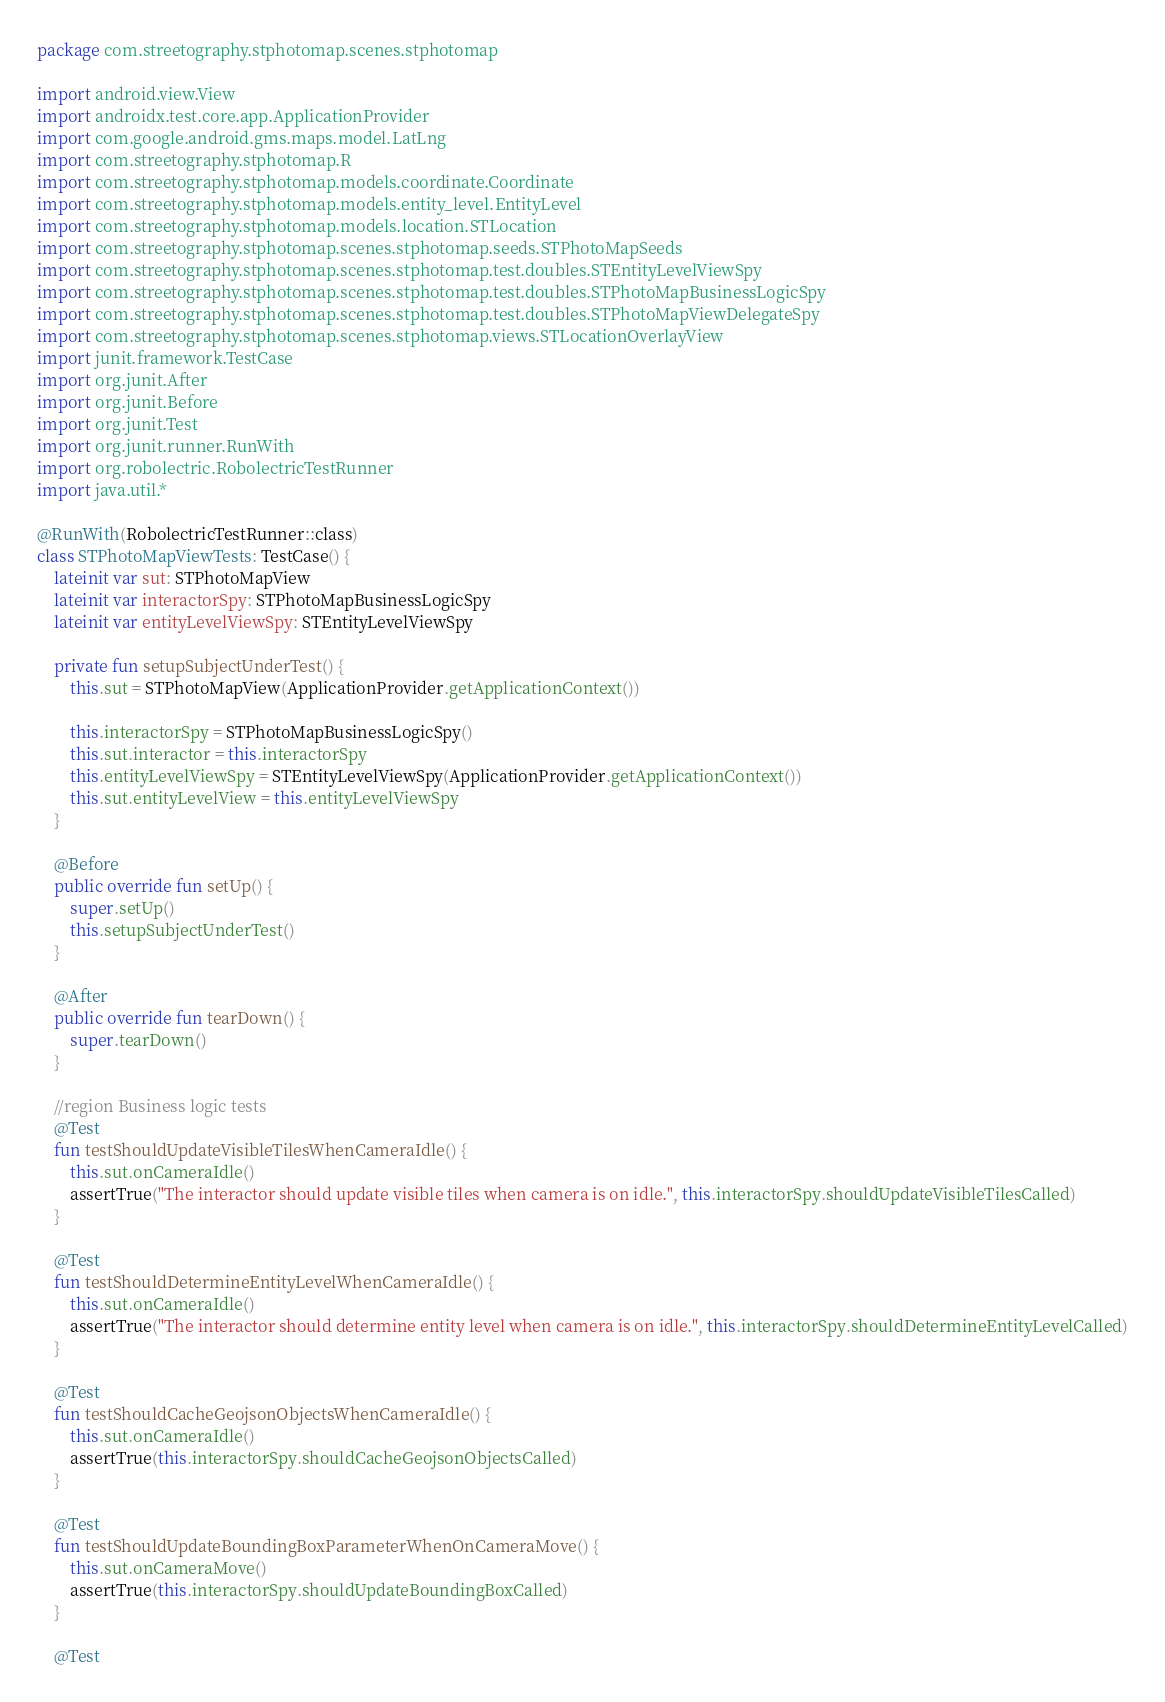Convert code to text. <code><loc_0><loc_0><loc_500><loc_500><_Kotlin_>package com.streetography.stphotomap.scenes.stphotomap

import android.view.View
import androidx.test.core.app.ApplicationProvider
import com.google.android.gms.maps.model.LatLng
import com.streetography.stphotomap.R
import com.streetography.stphotomap.models.coordinate.Coordinate
import com.streetography.stphotomap.models.entity_level.EntityLevel
import com.streetography.stphotomap.models.location.STLocation
import com.streetography.stphotomap.scenes.stphotomap.seeds.STPhotoMapSeeds
import com.streetography.stphotomap.scenes.stphotomap.test.doubles.STEntityLevelViewSpy
import com.streetography.stphotomap.scenes.stphotomap.test.doubles.STPhotoMapBusinessLogicSpy
import com.streetography.stphotomap.scenes.stphotomap.test.doubles.STPhotoMapViewDelegateSpy
import com.streetography.stphotomap.scenes.stphotomap.views.STLocationOverlayView
import junit.framework.TestCase
import org.junit.After
import org.junit.Before
import org.junit.Test
import org.junit.runner.RunWith
import org.robolectric.RobolectricTestRunner
import java.util.*

@RunWith(RobolectricTestRunner::class)
class STPhotoMapViewTests: TestCase() {
    lateinit var sut: STPhotoMapView
    lateinit var interactorSpy: STPhotoMapBusinessLogicSpy
    lateinit var entityLevelViewSpy: STEntityLevelViewSpy

    private fun setupSubjectUnderTest() {
        this.sut = STPhotoMapView(ApplicationProvider.getApplicationContext())

        this.interactorSpy = STPhotoMapBusinessLogicSpy()
        this.sut.interactor = this.interactorSpy
        this.entityLevelViewSpy = STEntityLevelViewSpy(ApplicationProvider.getApplicationContext())
        this.sut.entityLevelView = this.entityLevelViewSpy
    }

    @Before
    public override fun setUp() {
        super.setUp()
        this.setupSubjectUnderTest()
    }

    @After
    public override fun tearDown() {
        super.tearDown()
    }

    //region Business logic tests
    @Test
    fun testShouldUpdateVisibleTilesWhenCameraIdle() {
        this.sut.onCameraIdle()
        assertTrue("The interactor should update visible tiles when camera is on idle.", this.interactorSpy.shouldUpdateVisibleTilesCalled)
    }

    @Test
    fun testShouldDetermineEntityLevelWhenCameraIdle() {
        this.sut.onCameraIdle()
        assertTrue("The interactor should determine entity level when camera is on idle.", this.interactorSpy.shouldDetermineEntityLevelCalled)
    }

    @Test
    fun testShouldCacheGeojsonObjectsWhenCameraIdle() {
        this.sut.onCameraIdle()
        assertTrue(this.interactorSpy.shouldCacheGeojsonObjectsCalled)
    }

    @Test
    fun testShouldUpdateBoundingBoxParameterWhenOnCameraMove() {
        this.sut.onCameraMove()
        assertTrue(this.interactorSpy.shouldUpdateBoundingBoxCalled)
    }

    @Test</code> 